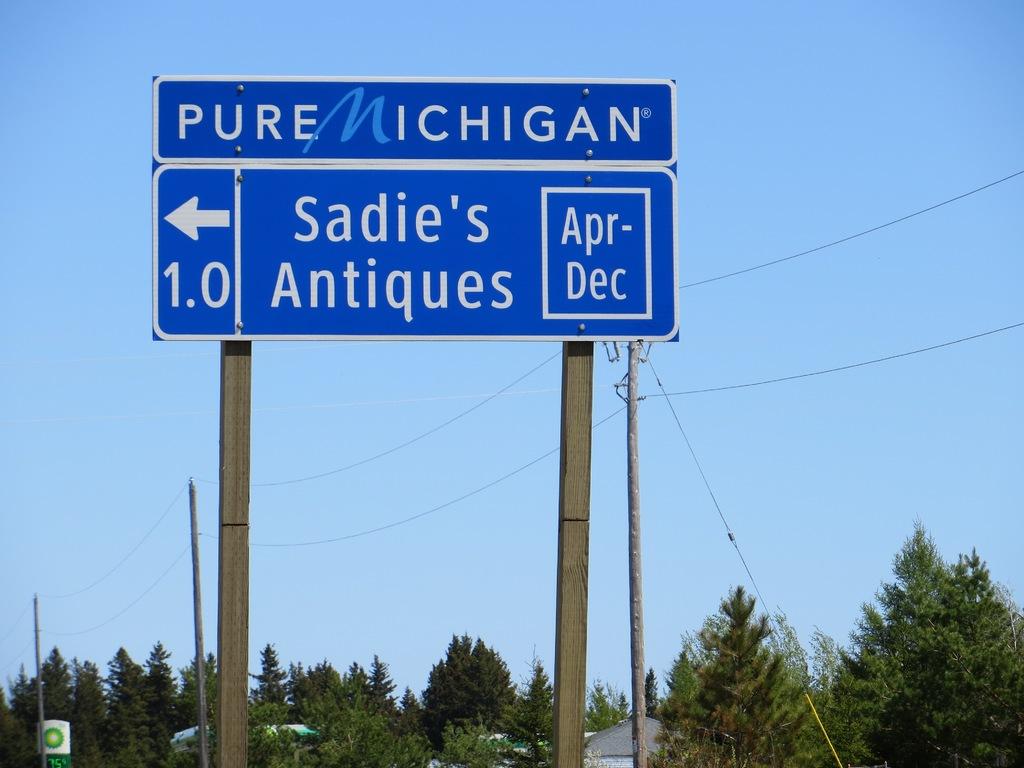How far away is sadie's antiques?
Make the answer very short. 1.0. What state is this in?
Your answer should be compact. Michigan. 